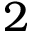<formula> <loc_0><loc_0><loc_500><loc_500>2</formula> 